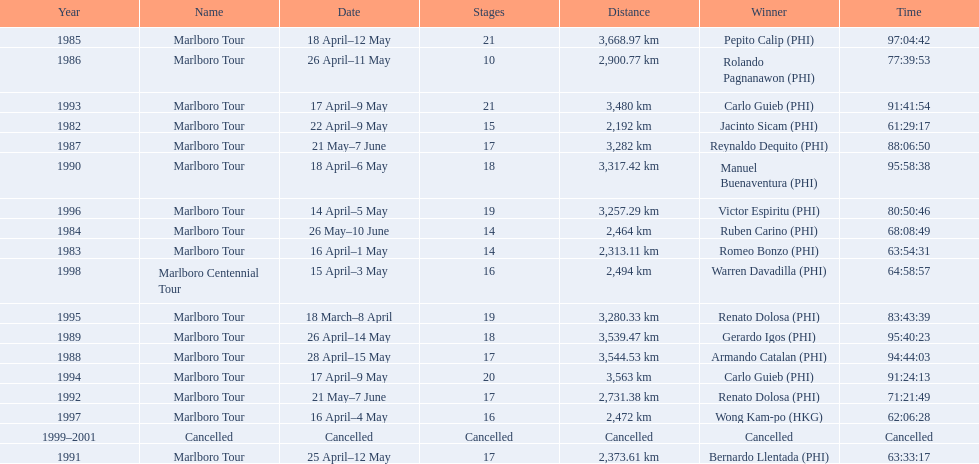How far did the marlboro tour travel each year? 2,192 km, 2,313.11 km, 2,464 km, 3,668.97 km, 2,900.77 km, 3,282 km, 3,544.53 km, 3,539.47 km, 3,317.42 km, 2,373.61 km, 2,731.38 km, 3,480 km, 3,563 km, 3,280.33 km, 3,257.29 km, 2,472 km, 2,494 km, Cancelled. In what year did they travel the furthest? 1985. How far did they travel that year? 3,668.97 km. 